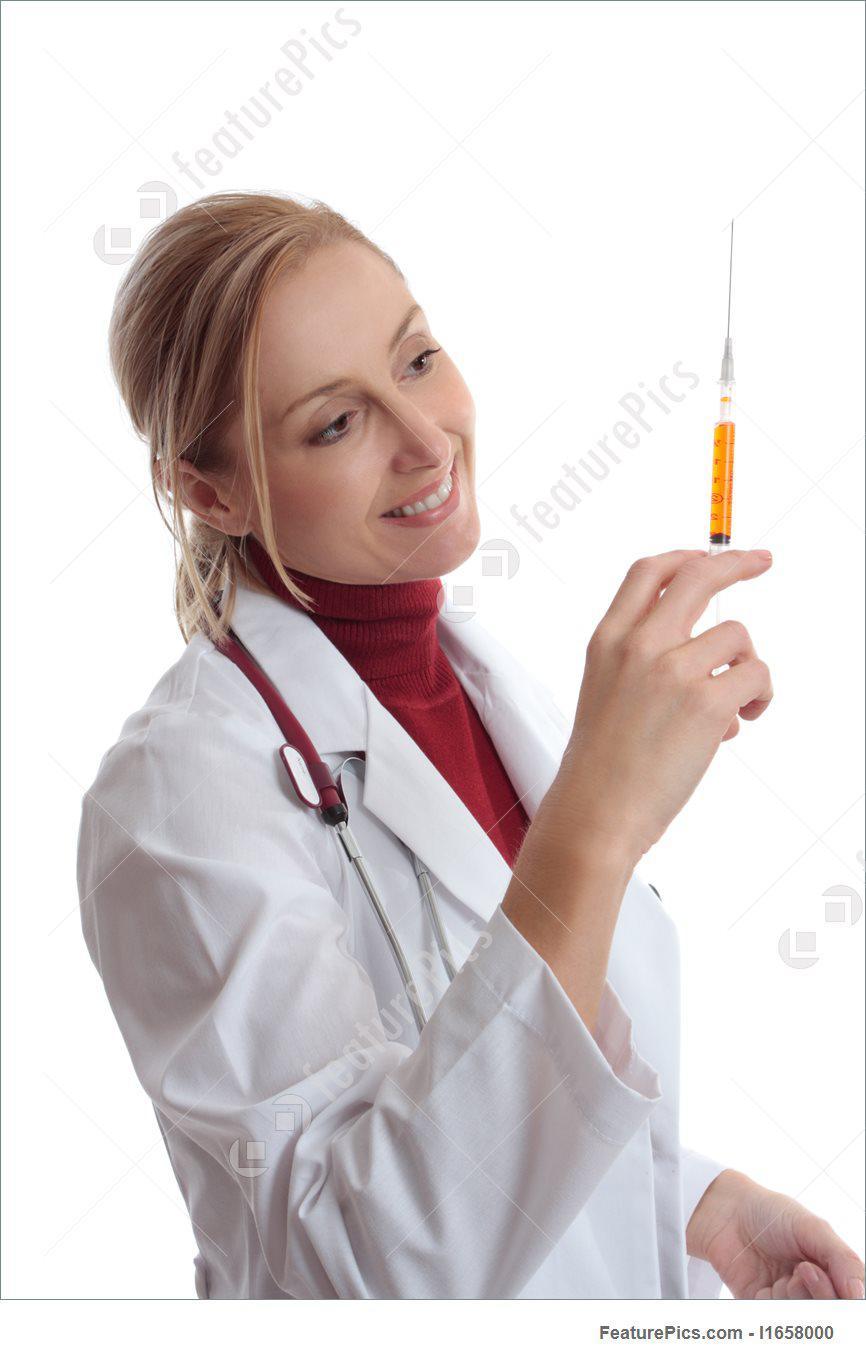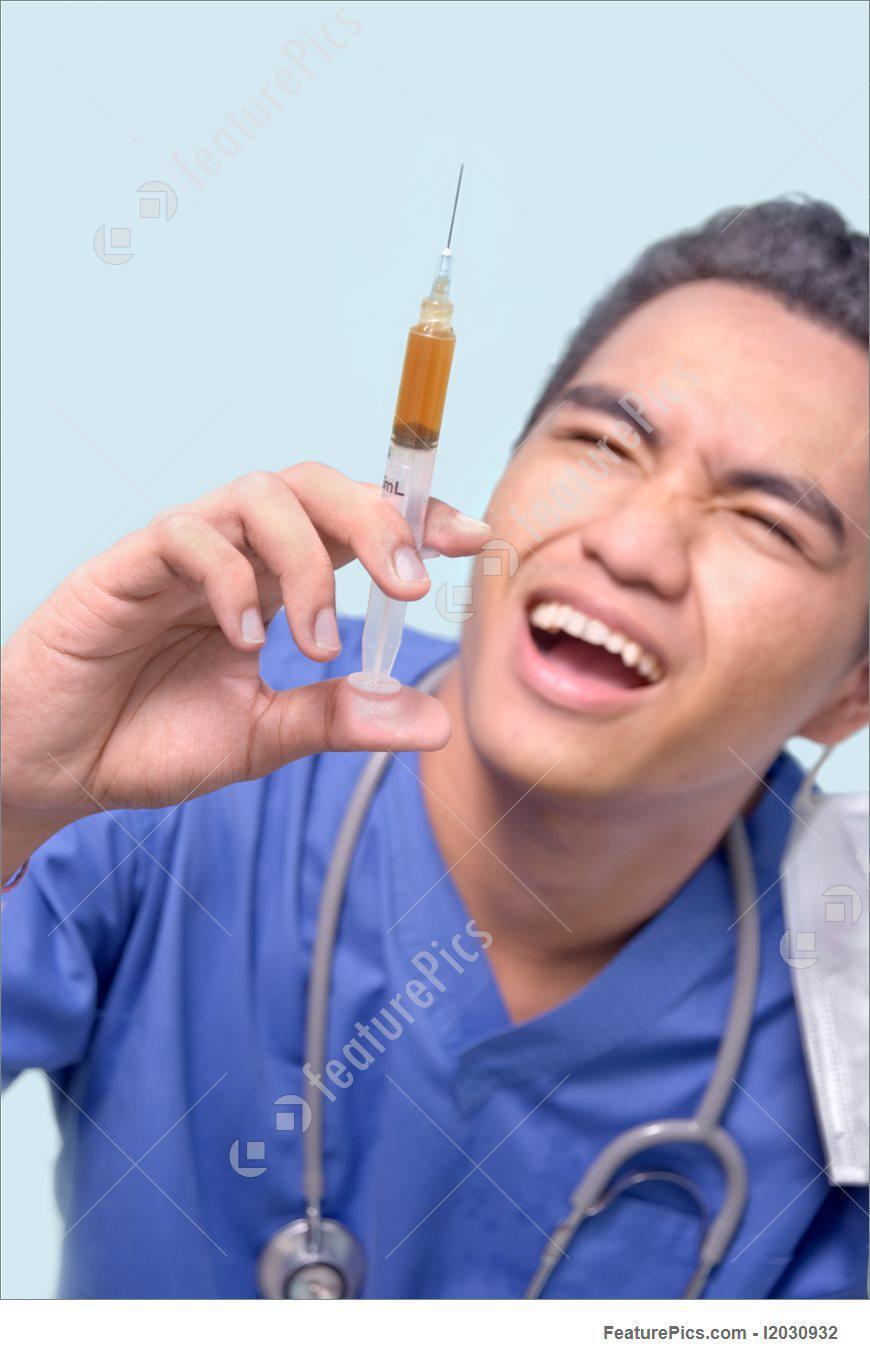The first image is the image on the left, the second image is the image on the right. Analyze the images presented: Is the assertion "A doctor is looking at a syringe." valid? Answer yes or no. Yes. 